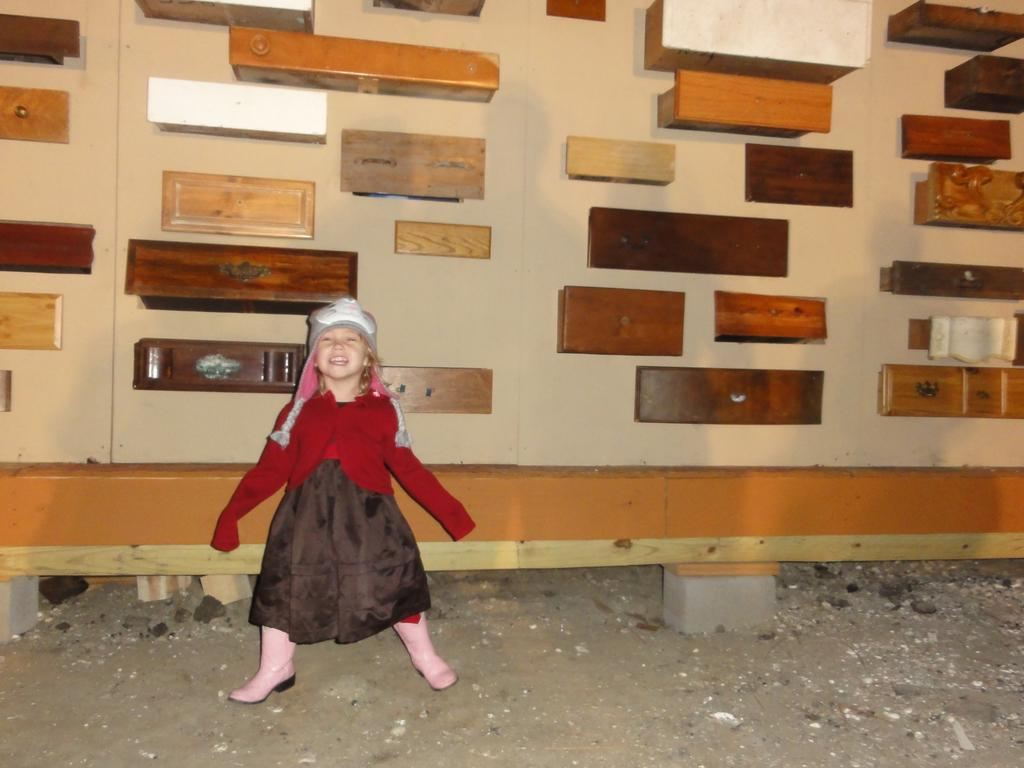Who is present in the image? There is a girl in the image. What is the girl doing in the image? The girl is smiling in the image. What is the girl wearing on her head? The girl is wearing a cap in the image. What can be seen in the background of the image? There is a wall in the background of the image, and wooden blocks are placed on the wall. What type of popcorn is the girl eating in the image? There is no popcorn present in the image; the girl is not eating anything. What skin condition does the girl have in the image? There is no indication of any skin condition in the image; the girl appears to have healthy skin. 